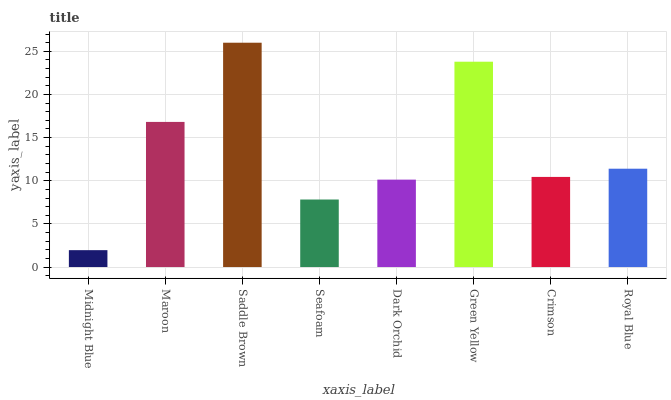Is Midnight Blue the minimum?
Answer yes or no. Yes. Is Saddle Brown the maximum?
Answer yes or no. Yes. Is Maroon the minimum?
Answer yes or no. No. Is Maroon the maximum?
Answer yes or no. No. Is Maroon greater than Midnight Blue?
Answer yes or no. Yes. Is Midnight Blue less than Maroon?
Answer yes or no. Yes. Is Midnight Blue greater than Maroon?
Answer yes or no. No. Is Maroon less than Midnight Blue?
Answer yes or no. No. Is Royal Blue the high median?
Answer yes or no. Yes. Is Crimson the low median?
Answer yes or no. Yes. Is Crimson the high median?
Answer yes or no. No. Is Green Yellow the low median?
Answer yes or no. No. 